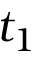<formula> <loc_0><loc_0><loc_500><loc_500>t _ { 1 }</formula> 